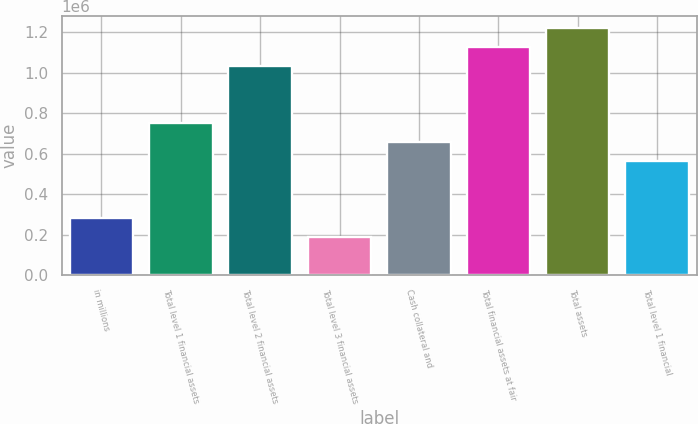Convert chart. <chart><loc_0><loc_0><loc_500><loc_500><bar_chart><fcel>in millions<fcel>Total level 1 financial assets<fcel>Total level 2 financial assets<fcel>Total level 3 financial assets<fcel>Cash collateral and<fcel>Total financial assets at fair<fcel>Total assets<fcel>Total level 1 financial<nl><fcel>281570<fcel>750845<fcel>1.03241e+06<fcel>187715<fcel>656990<fcel>1.12626e+06<fcel>1.22012e+06<fcel>563135<nl></chart> 